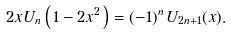<formula> <loc_0><loc_0><loc_500><loc_500>2 x U _ { n } \left ( \, 1 - 2 x ^ { 2 } \, \right ) = ( - 1 ) ^ { n } \, U _ { 2 n + 1 } ( x ) .</formula> 